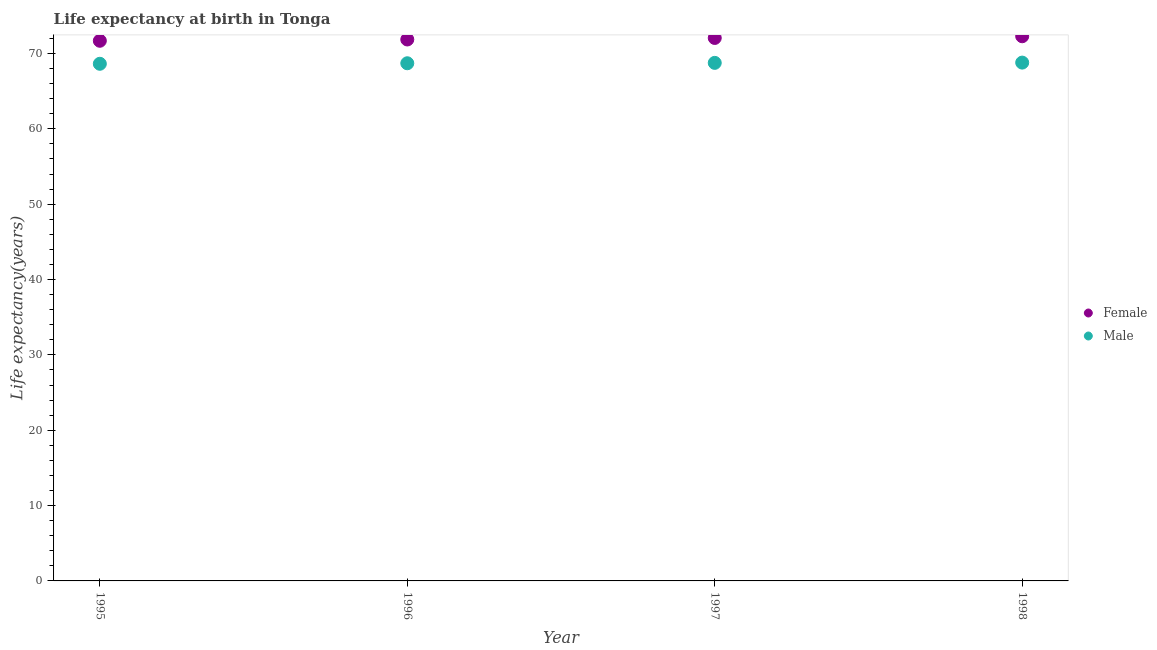What is the life expectancy(female) in 1995?
Offer a terse response. 71.68. Across all years, what is the maximum life expectancy(male)?
Provide a short and direct response. 68.79. Across all years, what is the minimum life expectancy(female)?
Your response must be concise. 71.68. In which year was the life expectancy(male) maximum?
Keep it short and to the point. 1998. What is the total life expectancy(female) in the graph?
Keep it short and to the point. 287.88. What is the difference between the life expectancy(female) in 1997 and that in 1998?
Your answer should be compact. -0.23. What is the difference between the life expectancy(male) in 1997 and the life expectancy(female) in 1995?
Your answer should be very brief. -2.93. What is the average life expectancy(male) per year?
Make the answer very short. 68.72. In the year 1998, what is the difference between the life expectancy(female) and life expectancy(male)?
Ensure brevity in your answer.  3.5. In how many years, is the life expectancy(male) greater than 20 years?
Offer a very short reply. 4. What is the ratio of the life expectancy(female) in 1995 to that in 1997?
Make the answer very short. 0.99. Is the life expectancy(male) in 1996 less than that in 1997?
Your answer should be compact. Yes. Is the difference between the life expectancy(male) in 1995 and 1996 greater than the difference between the life expectancy(female) in 1995 and 1996?
Keep it short and to the point. Yes. What is the difference between the highest and the second highest life expectancy(female)?
Keep it short and to the point. 0.23. What is the difference between the highest and the lowest life expectancy(male)?
Provide a short and direct response. 0.16. Is the sum of the life expectancy(male) in 1997 and 1998 greater than the maximum life expectancy(female) across all years?
Ensure brevity in your answer.  Yes. Does the life expectancy(female) monotonically increase over the years?
Provide a short and direct response. Yes. Is the life expectancy(female) strictly greater than the life expectancy(male) over the years?
Offer a terse response. Yes. Is the life expectancy(female) strictly less than the life expectancy(male) over the years?
Offer a terse response. No. What is the difference between two consecutive major ticks on the Y-axis?
Your response must be concise. 10. Does the graph contain any zero values?
Offer a terse response. No. Does the graph contain grids?
Provide a short and direct response. No. How many legend labels are there?
Provide a succinct answer. 2. How are the legend labels stacked?
Your response must be concise. Vertical. What is the title of the graph?
Offer a terse response. Life expectancy at birth in Tonga. Does "Canada" appear as one of the legend labels in the graph?
Your answer should be very brief. No. What is the label or title of the Y-axis?
Offer a very short reply. Life expectancy(years). What is the Life expectancy(years) in Female in 1995?
Give a very brief answer. 71.68. What is the Life expectancy(years) of Male in 1995?
Make the answer very short. 68.63. What is the Life expectancy(years) in Female in 1996?
Offer a terse response. 71.86. What is the Life expectancy(years) of Male in 1996?
Ensure brevity in your answer.  68.7. What is the Life expectancy(years) of Female in 1997?
Make the answer very short. 72.06. What is the Life expectancy(years) in Male in 1997?
Offer a terse response. 68.75. What is the Life expectancy(years) in Female in 1998?
Provide a short and direct response. 72.28. What is the Life expectancy(years) of Male in 1998?
Ensure brevity in your answer.  68.79. Across all years, what is the maximum Life expectancy(years) of Female?
Ensure brevity in your answer.  72.28. Across all years, what is the maximum Life expectancy(years) in Male?
Ensure brevity in your answer.  68.79. Across all years, what is the minimum Life expectancy(years) in Female?
Make the answer very short. 71.68. Across all years, what is the minimum Life expectancy(years) in Male?
Give a very brief answer. 68.63. What is the total Life expectancy(years) in Female in the graph?
Give a very brief answer. 287.88. What is the total Life expectancy(years) in Male in the graph?
Provide a succinct answer. 274.87. What is the difference between the Life expectancy(years) of Female in 1995 and that in 1996?
Provide a short and direct response. -0.17. What is the difference between the Life expectancy(years) in Male in 1995 and that in 1996?
Provide a succinct answer. -0.07. What is the difference between the Life expectancy(years) of Female in 1995 and that in 1997?
Offer a very short reply. -0.37. What is the difference between the Life expectancy(years) of Male in 1995 and that in 1997?
Keep it short and to the point. -0.12. What is the difference between the Life expectancy(years) of Female in 1995 and that in 1998?
Provide a short and direct response. -0.6. What is the difference between the Life expectancy(years) of Male in 1995 and that in 1998?
Offer a terse response. -0.16. What is the difference between the Life expectancy(years) of Female in 1996 and that in 1997?
Your answer should be very brief. -0.2. What is the difference between the Life expectancy(years) of Male in 1996 and that in 1997?
Keep it short and to the point. -0.05. What is the difference between the Life expectancy(years) of Female in 1996 and that in 1998?
Keep it short and to the point. -0.43. What is the difference between the Life expectancy(years) of Male in 1996 and that in 1998?
Keep it short and to the point. -0.09. What is the difference between the Life expectancy(years) of Female in 1997 and that in 1998?
Your answer should be compact. -0.23. What is the difference between the Life expectancy(years) of Male in 1997 and that in 1998?
Your answer should be compact. -0.04. What is the difference between the Life expectancy(years) of Female in 1995 and the Life expectancy(years) of Male in 1996?
Give a very brief answer. 2.98. What is the difference between the Life expectancy(years) of Female in 1995 and the Life expectancy(years) of Male in 1997?
Offer a terse response. 2.93. What is the difference between the Life expectancy(years) in Female in 1995 and the Life expectancy(years) in Male in 1998?
Make the answer very short. 2.9. What is the difference between the Life expectancy(years) of Female in 1996 and the Life expectancy(years) of Male in 1997?
Give a very brief answer. 3.1. What is the difference between the Life expectancy(years) in Female in 1996 and the Life expectancy(years) in Male in 1998?
Make the answer very short. 3.07. What is the difference between the Life expectancy(years) of Female in 1997 and the Life expectancy(years) of Male in 1998?
Offer a very short reply. 3.27. What is the average Life expectancy(years) of Female per year?
Give a very brief answer. 71.97. What is the average Life expectancy(years) in Male per year?
Provide a short and direct response. 68.72. In the year 1995, what is the difference between the Life expectancy(years) of Female and Life expectancy(years) of Male?
Provide a succinct answer. 3.05. In the year 1996, what is the difference between the Life expectancy(years) in Female and Life expectancy(years) in Male?
Make the answer very short. 3.16. In the year 1997, what is the difference between the Life expectancy(years) in Female and Life expectancy(years) in Male?
Your answer should be compact. 3.31. In the year 1998, what is the difference between the Life expectancy(years) in Female and Life expectancy(years) in Male?
Ensure brevity in your answer.  3.5. What is the ratio of the Life expectancy(years) in Male in 1995 to that in 1996?
Make the answer very short. 1. What is the ratio of the Life expectancy(years) in Female in 1995 to that in 1998?
Give a very brief answer. 0.99. What is the ratio of the Life expectancy(years) of Male in 1996 to that in 1997?
Give a very brief answer. 1. What is the ratio of the Life expectancy(years) in Male in 1996 to that in 1998?
Offer a very short reply. 1. What is the ratio of the Life expectancy(years) of Male in 1997 to that in 1998?
Ensure brevity in your answer.  1. What is the difference between the highest and the second highest Life expectancy(years) in Female?
Provide a short and direct response. 0.23. What is the difference between the highest and the second highest Life expectancy(years) of Male?
Your answer should be very brief. 0.04. What is the difference between the highest and the lowest Life expectancy(years) in Female?
Provide a short and direct response. 0.6. What is the difference between the highest and the lowest Life expectancy(years) in Male?
Keep it short and to the point. 0.16. 